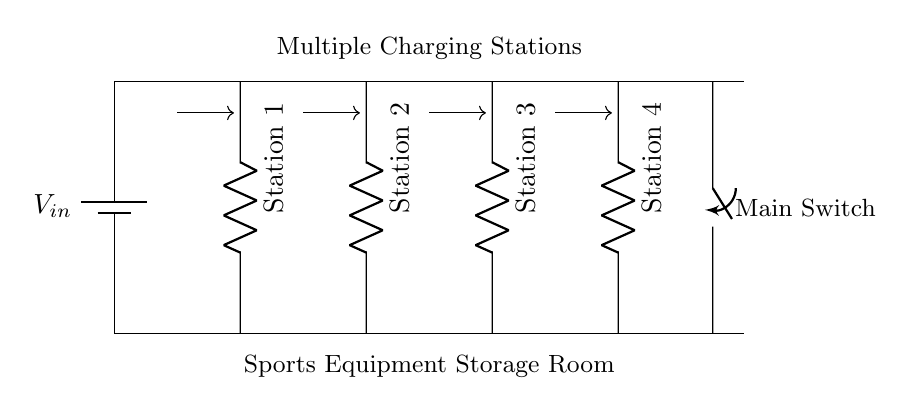What is the type of circuit shown? The circuit is a parallel circuit design as evidenced by the multiple branches connecting to the same voltage source without sharing current paths.
Answer: Parallel How many charging stations are present? There are four charging stations visible in the diagram, each represented by a resistor symbol, indicating their parallel connection to the main voltage line.
Answer: Four What is located at the top of the circuit? At the top of the circuit, there is a battery symbol representing the main power source for the charging stations, supplying voltage to the entire circuit.
Answer: Battery What function does the switch serve in this circuit? The switch allows for the control of the entire circuit by turning the power supply on or off, thereby managing the operation of all connected charging stations simultaneously.
Answer: Control What can be inferred about the current flow in this setup? Since it is a parallel circuit, the current from the battery splits among the stations, and each charging station can draw its required current independently, leading to more efficient charging.
Answer: Splitting What does the labeling indicate about the overall application of this circuit? The labels indicate that this circuit is designed for a sports equipment storage room, specifically facilitating the charging of various sports equipment, reflecting its practical application.
Answer: Sports equipment storage 